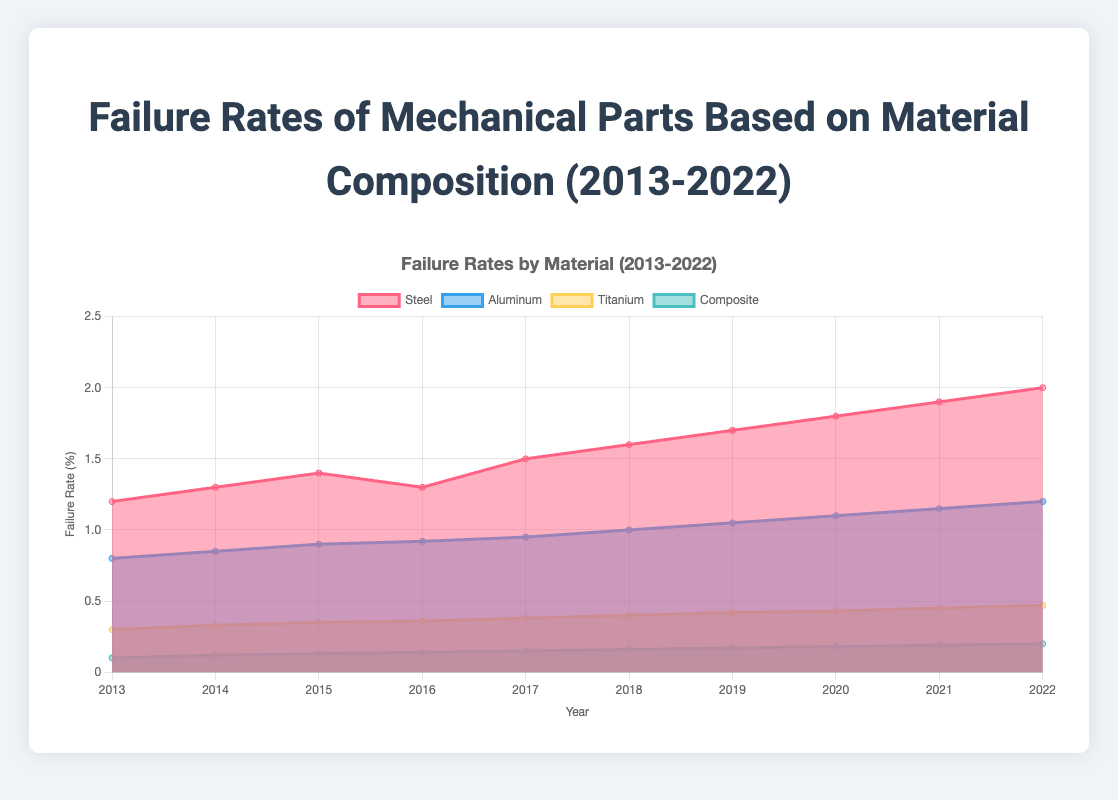What is the overall trend in the failure rates of Steel from 2013 to 2022? The failure rate for Steel has been consistently increasing over the years, starting from 1.2 in 2013 to reaching 2.0 in 2022.
Answer: Increasing Which material had the lowest failure rate in 2022? By comparing the failure rates in 2022, Composite had the lowest failure rate at 0.2, compared to Steel, Aluminum, and Titanium.
Answer: Composite What year saw the sharpest increase in the failure rate of Aluminum? Observing the differences in Aluminum’s failure rates each year, the sharpest increase was between 2014 (0.85) and 2015 (0.9), with a 0.05 increase.
Answer: Between 2014 and 2015 How much did the failure rate of Titanium increase from 2013 to 2022? The failure rate for Titanium in 2013 was 0.3, and it was 0.47 in 2022, making the increase 0.47 - 0.3 = 0.17.
Answer: 0.17 Of the four materials, which one showed the most consistent incremental increase in failure rates over the 10-year period? By analyzing the data, Aluminum shows the most consistent increment in its failure rates, with an increase almost every year (from 0.8 in 2013 to 1.2 in 2022).
Answer: Aluminum Which year did Steel have a failure rate equal to the failure rate Aluminum had in 2015? Steel's failure rate in 2015 was 1.4, the same as Aluminum's failure rate of 1.4 in 2021.
Answer: 2021 Did the failure rate of Composite ever surpass Titanium throughout the period? Reviewing the data, Composite’s highest rate in 2022 (0.2) never exceeded Titanium’s lowest rate in 2013 (0.3).
Answer: No By how much did the failure rate of Steel and Aluminum differ in 2013? Steel's failure rate in 2013 was 1.2, and Aluminum's was 0.8. The difference is 1.2 - 0.8 = 0.4.
Answer: 0.4 How many different materials are represented in the figure? The figure includes data for four materials: Steel, Aluminum, Titanium, and Composite.
Answer: 4 What is the average failure rate of Composite over the 10 years? Summing Composite's failure rates over the years (0.1 + 0.12 + 0.13 + 0.14 + 0.15 + 0.16 + 0.17 + 0.18 + 0.19 + 0.2) equals 1.54. Dividing by 10, the average is 1.54 / 10 = 0.154.
Answer: 0.154 